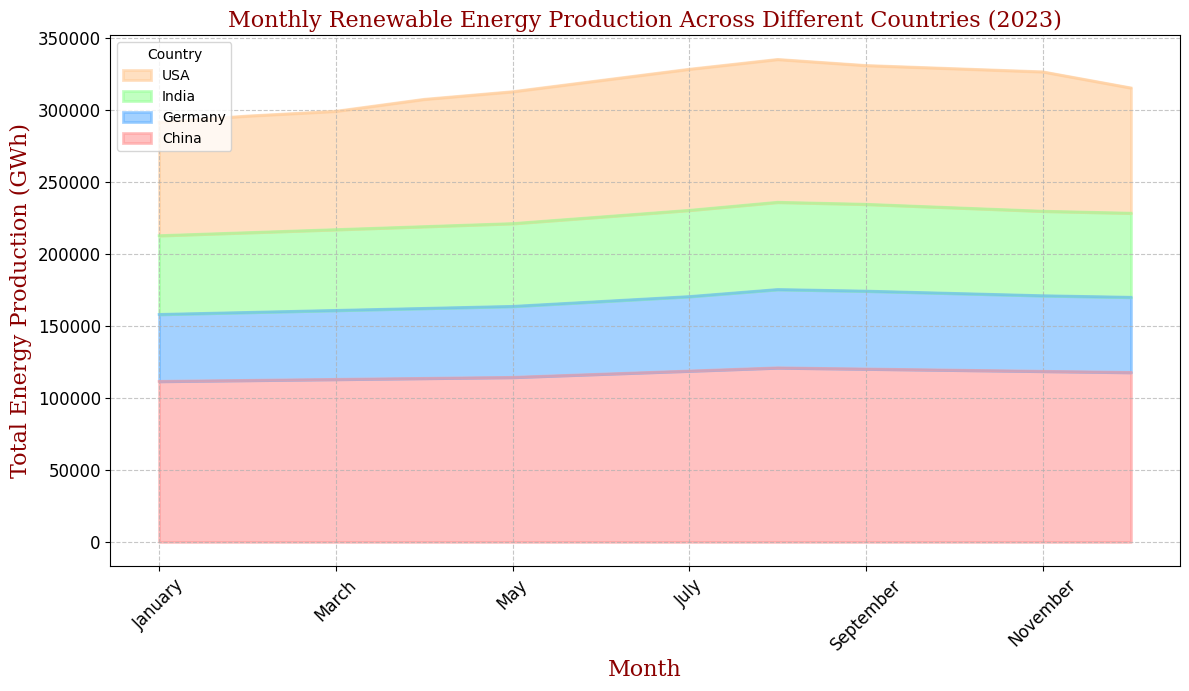Which month had the highest total energy production in the USA? Looking at the area chart for the USA, find the month where the height of the area is maximized. This corresponds to the highest total energy production. July shows the maximum height for the USA.
Answer: July Between Germany and India, which country had higher renewable energy production in September 2023? Compare the heights of the areas representing Germany and India for September. The area for Germany is higher than that for India.
Answer: Germany What's the average renewable energy production for China from June to August 2023? Sum the total energy production values for China in June, July, and August, and divide by 3. (45000 + 44000 + 46000) / 3 = 45000 GWh
Answer: 45000 GWh How did renewable energy production in the USA change from January to June 2023? Observe the trend in the height of the USA's area from January to June. The area increases steadily from January to June.
Answer: Increased Which countries had a decrease in renewable energy production from August to December 2023? Look at the areas for each country from August to December to identify which ones decreased in height. The countries with decreasing areas are China and India.
Answer: China, India Was Germany's renewable energy production higher in May or October 2023? Compare the height of Germany's area in May and October. The area for May is slightly higher than for October.
Answer: May What is the approximate difference in total energy production between China and the USA in December 2023? Find the height difference of the areas representing China and the USA for December. China’s value is approximately 19000 GWh higher than the USA’s.
Answer: 19000 GWh Which country showed the most fluctuation in renewable energy production throughout 2023? To find the country, look at the variation in the heights of the areas over the months. The area of the USA shows the most fluctuation with significant increases and decreases.
Answer: USA In which month did India have the lowest renewable energy production in 2023? Identify the month where the height of India’s area is the smallest. January shows the lowest height for India.
Answer: January 